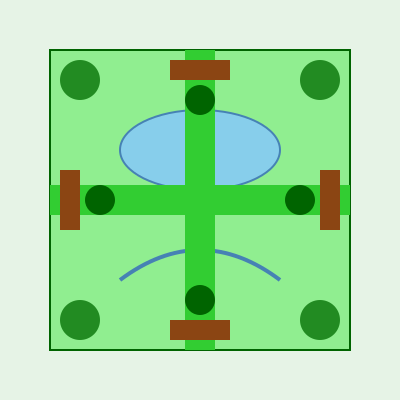Based on the golf course layout shown, which design feature contributes most significantly to minimizing environmental impact while maintaining playability? To determine the most environmentally friendly feature of this golf course layout, let's analyze each element:

1. Compact design: The course is designed in a square shape, minimizing land use.

2. Water features: There's a lake and a stream, which can serve as natural habitats and water retention systems.

3. Trees: Four clusters of trees are positioned at the corners, providing wildlife habitats and natural boundaries.

4. Fairway layout: The fairways form a cross shape, maximizing space efficiency.

5. Multiple tees and greens: Each fairway has tees at both ends and greens in the middle, allowing for versatile play without additional land use.

Among these features, the cross-shaped fairway layout stands out as the most significant contributor to minimizing environmental impact while maintaining playability. This design:

a) Reduces the total area needed for playable surfaces.
b) Allows for multiple hole configurations within a smaller footprint.
c) Minimizes the need for additional irrigation and maintenance.
d) Leaves more space for natural areas and habitats around the edges.

The cross-shaped layout effectively doubles the utilization of the same land area, reducing the overall environmental footprint of the golf course while still providing a full golfing experience.
Answer: Cross-shaped fairway layout 